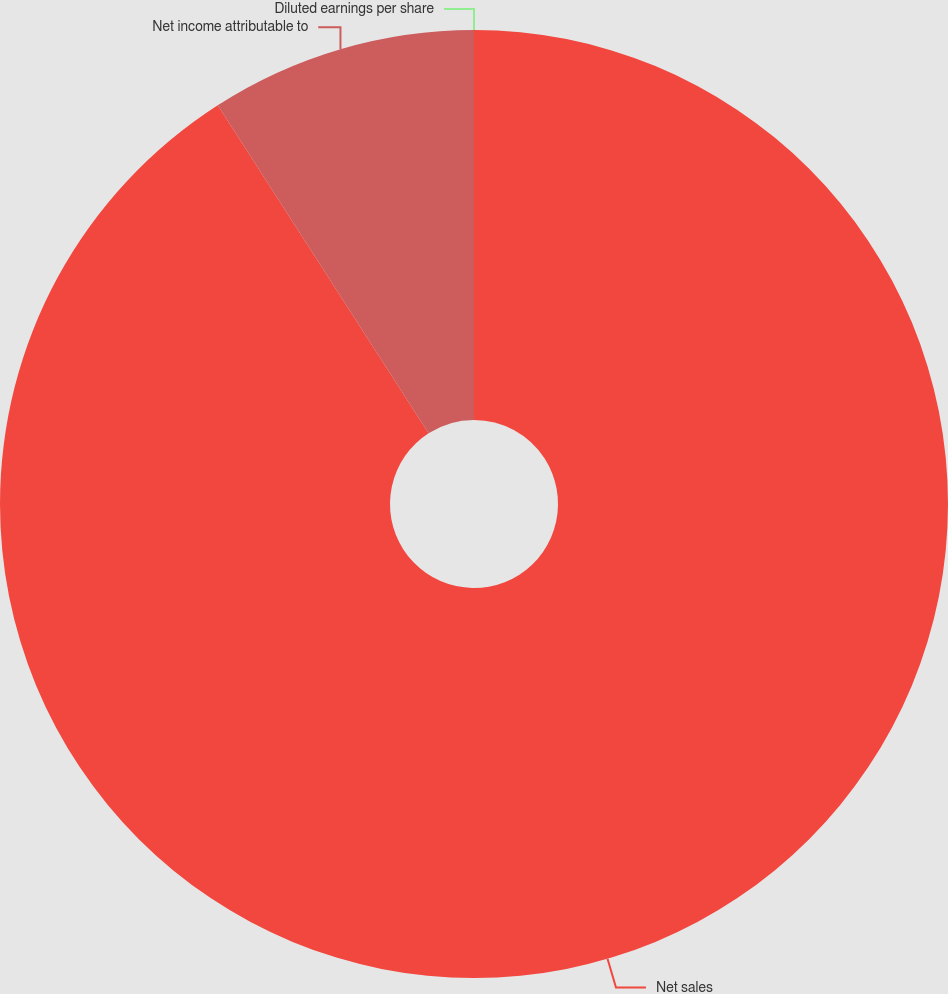Convert chart. <chart><loc_0><loc_0><loc_500><loc_500><pie_chart><fcel>Net sales<fcel>Net income attributable to<fcel>Diluted earnings per share<nl><fcel>90.91%<fcel>9.09%<fcel>0.0%<nl></chart> 